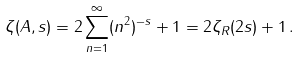Convert formula to latex. <formula><loc_0><loc_0><loc_500><loc_500>\zeta ( A , s ) = 2 \sum _ { n = 1 } ^ { \infty } ( n ^ { 2 } ) ^ { - s } + 1 = 2 \zeta _ { R } ( 2 s ) + 1 \, .</formula> 